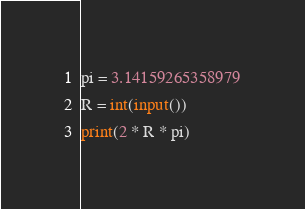<code> <loc_0><loc_0><loc_500><loc_500><_Python_>pi = 3.14159265358979
R = int(input())
print(2 * R * pi)</code> 